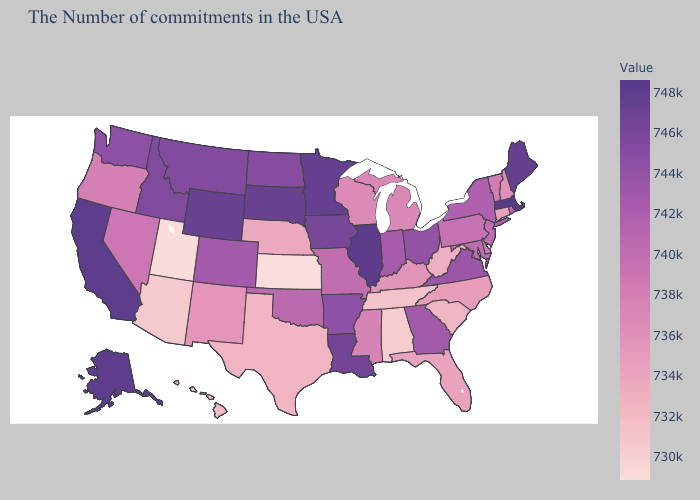Does South Dakota have the highest value in the USA?
Be succinct. No. Does Massachusetts have the highest value in the Northeast?
Be succinct. Yes. Among the states that border New York , which have the lowest value?
Keep it brief. Connecticut. Among the states that border Nevada , which have the lowest value?
Give a very brief answer. Utah. 